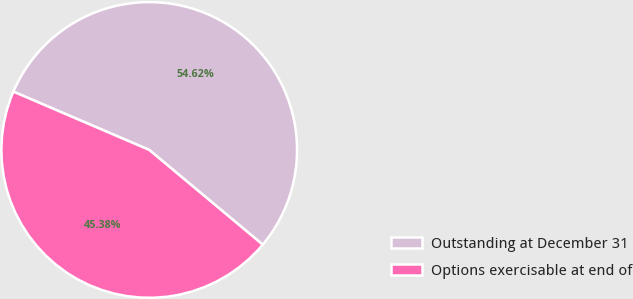<chart> <loc_0><loc_0><loc_500><loc_500><pie_chart><fcel>Outstanding at December 31<fcel>Options exercisable at end of<nl><fcel>54.62%<fcel>45.38%<nl></chart> 